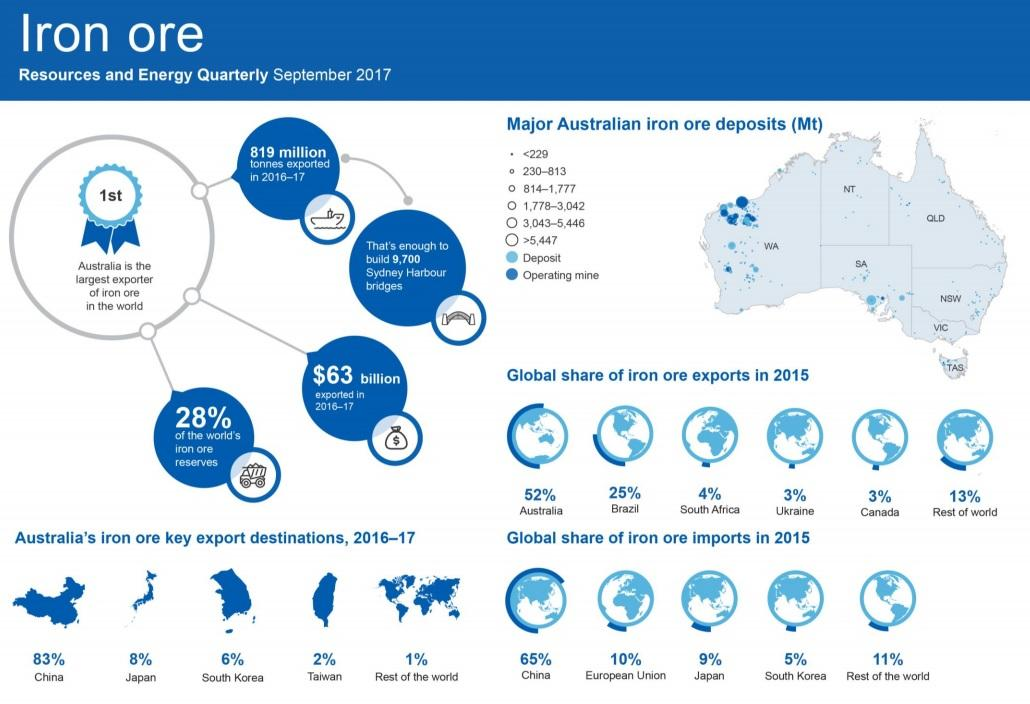Identify some key points in this picture. Australia has been divided into seven regions based on iron ore deposits. The region with the most active mining operations is located in Western Australia. Australia exports iron ore to five key destinations. The combined share of iron exports from Australia, Brazil, South Africa, Ukraine, and Canada is 87%. In 2015, Japan had the second lowest share of iron ore imports among all countries. 